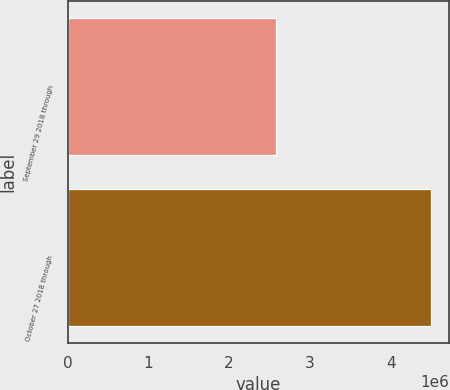Convert chart to OTSL. <chart><loc_0><loc_0><loc_500><loc_500><bar_chart><fcel>September 29 2018 through<fcel>October 27 2018 through<nl><fcel>2.58488e+06<fcel>4.49905e+06<nl></chart> 